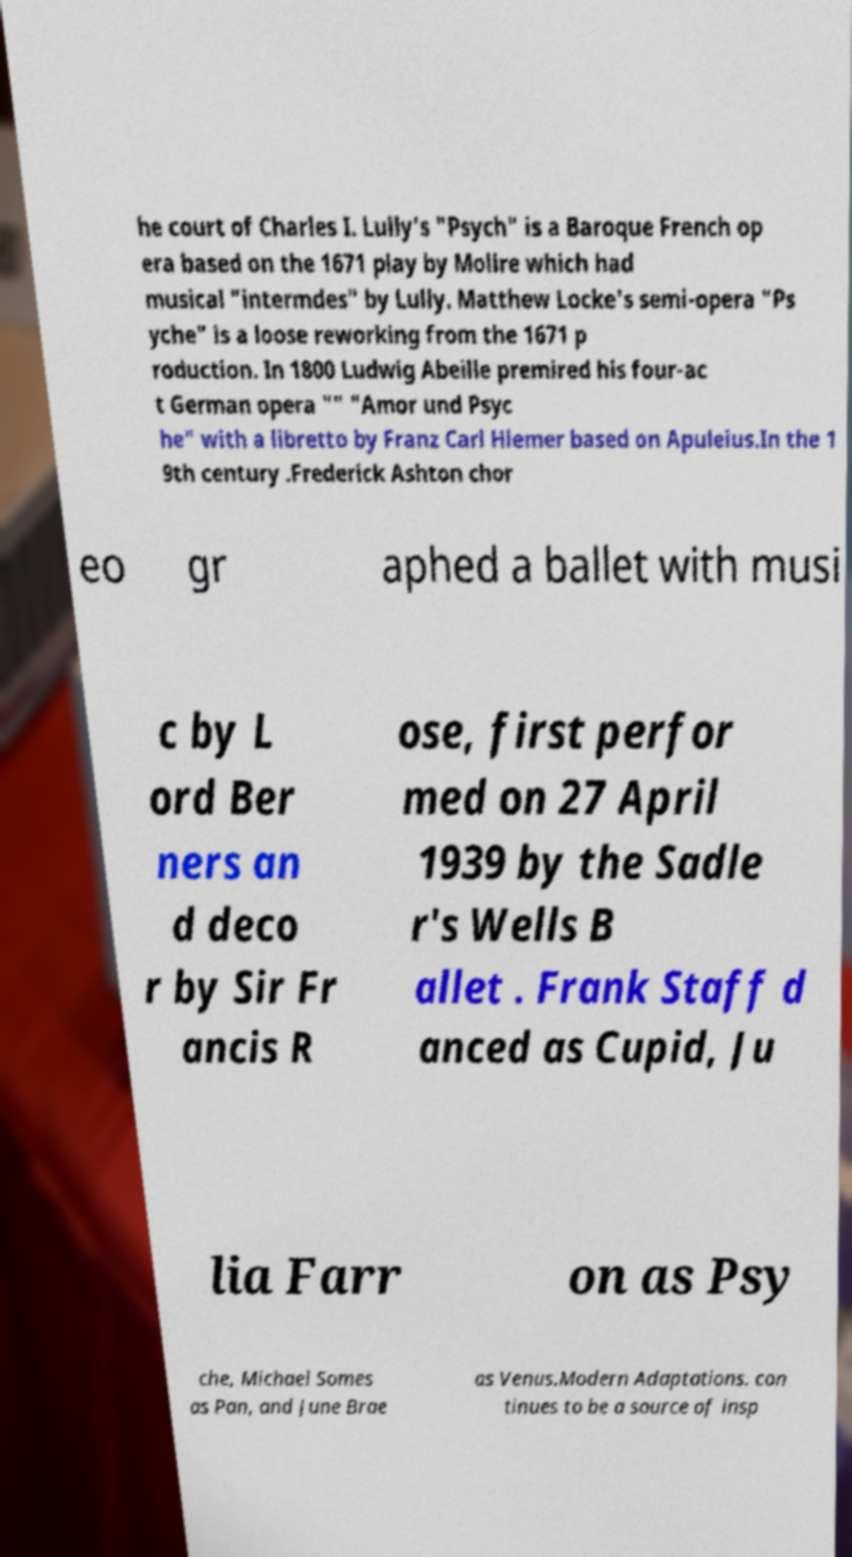Please read and relay the text visible in this image. What does it say? he court of Charles I. Lully's "Psych" is a Baroque French op era based on the 1671 play by Molire which had musical "intermdes" by Lully. Matthew Locke's semi-opera "Ps yche" is a loose reworking from the 1671 p roduction. In 1800 Ludwig Abeille premired his four-ac t German opera "" "Amor und Psyc he" with a libretto by Franz Carl Hiemer based on Apuleius.In the 1 9th century .Frederick Ashton chor eo gr aphed a ballet with musi c by L ord Ber ners an d deco r by Sir Fr ancis R ose, first perfor med on 27 April 1939 by the Sadle r's Wells B allet . Frank Staff d anced as Cupid, Ju lia Farr on as Psy che, Michael Somes as Pan, and June Brae as Venus.Modern Adaptations. con tinues to be a source of insp 